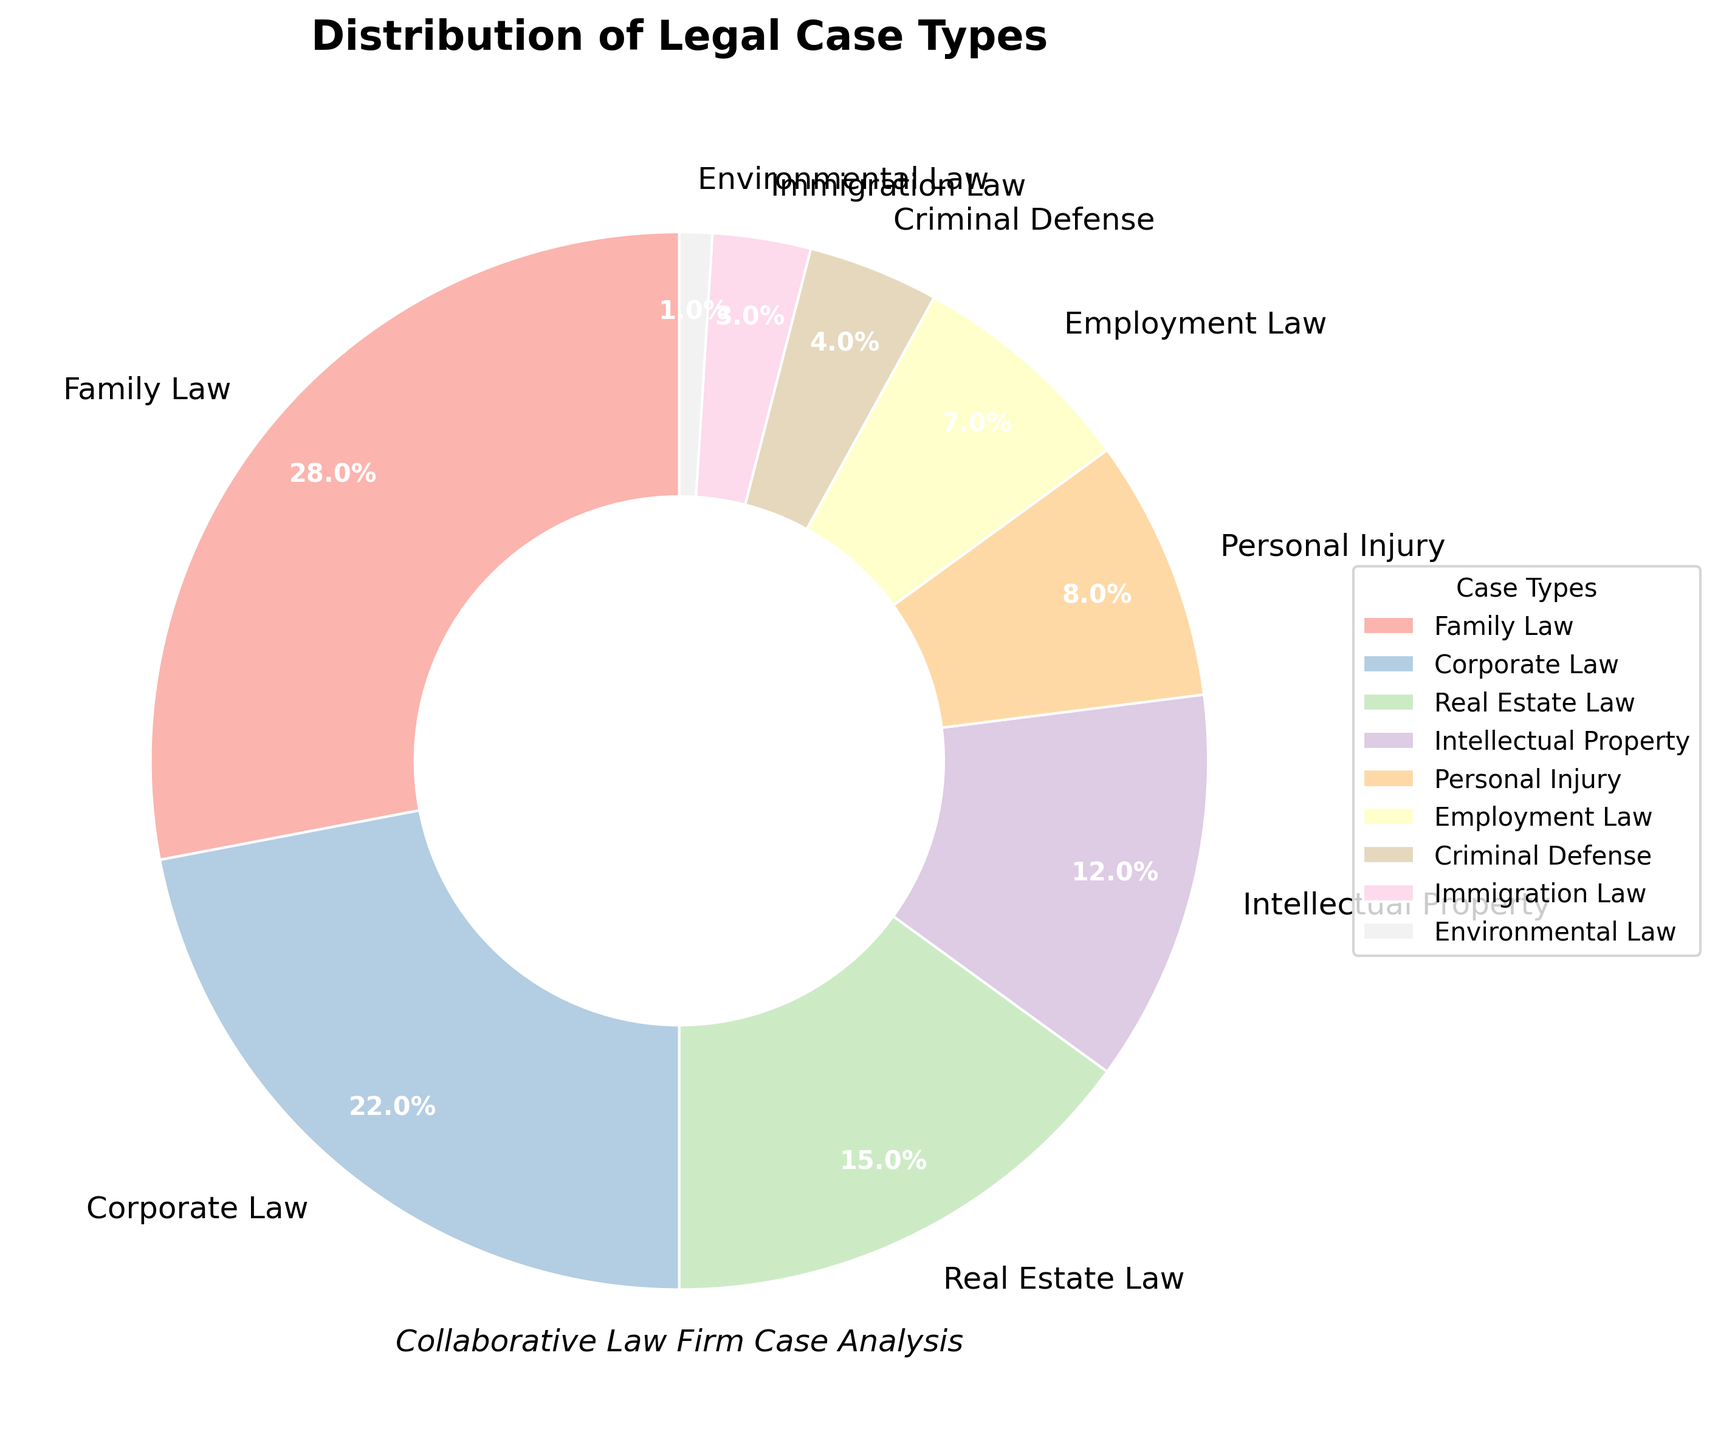What percentage of cases does Family Law handle? Family Law is represented as one of the segments in the pie chart. By examining the chart, the label and percentage next to Family Law indicate its portion of the total.
Answer: 28% What is the difference in percentage between Corporate Law and Employment Law cases? To find the difference, subtract the percentage of Employment Law cases from the percentage of Corporate Law cases: 22% - 7% = 15%.
Answer: 15% Which case type handles more cases: Real Estate Law or Personal Injury? Compare the percentages for Real Estate Law (15%) and Personal Injury (8%) to determine which is higher.
Answer: Real Estate Law What are the combined percentages of Family Law and Corporate Law cases? Add the percentages of Family Law (28%) and Corporate Law (22%) to find the combined total: 28% + 22% = 50%.
Answer: 50% Is the percentage of Intellectual Property cases greater than Immigration Law cases? Compare the percentage of Intellectual Property cases (12%) with Immigration Law cases (3%) to see if the former is greater.
Answer: Yes What is the average percentage of Employment Law, Criminal Defense, and Immigration Law cases? First, add the percentages for these case types: 7% + 4% + 3% = 14%. Then, divide by the number of case types: 14% / 3 = 4.67%.
Answer: 4.67% How much more prevalent is Family Law compared to Criminal Defense? Calculate the difference in their percentages: 28% - 4% = 24%.
Answer: 24% What percentage of the total cases do Environmental Law and Immigration Law combined account for? Add the percentages of Environmental Law (1%) and Immigration Law (3%): 1% + 3% = 4%.
Answer: 4% If you were to group Intellectual Property and Environmental Law together, what percentage of the total cases would this group represent? Add the percentages of Intellectual Property (12%) and Environmental Law (1%): 12% + 1% = 13%.
Answer: 13% Which case type is visually the smallest segment, and what percentage does it represent? Identify the smallest segment in the pie chart, which is labeled as Environmental Law with a percentage of 1%.
Answer: Environmental Law, 1% 